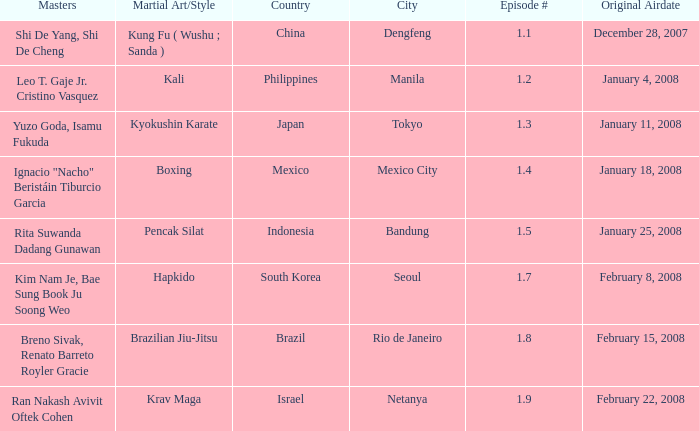Which martial arts style was shown in Rio de Janeiro? Brazilian Jiu-Jitsu. 